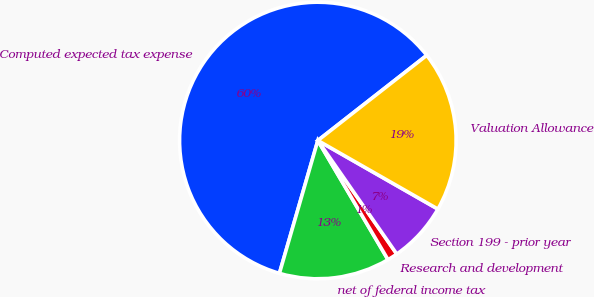Convert chart to OTSL. <chart><loc_0><loc_0><loc_500><loc_500><pie_chart><fcel>Computed expected tax expense<fcel>net of federal income tax<fcel>Research and development<fcel>Section 199 - prior year<fcel>Valuation Allowance<nl><fcel>59.95%<fcel>12.95%<fcel>1.2%<fcel>7.07%<fcel>18.82%<nl></chart> 